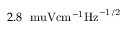<formula> <loc_0><loc_0><loc_500><loc_500>2 . 8 \ \ m u V { c m } ^ { - 1 } { H z } ^ { - 1 / 2 }</formula> 